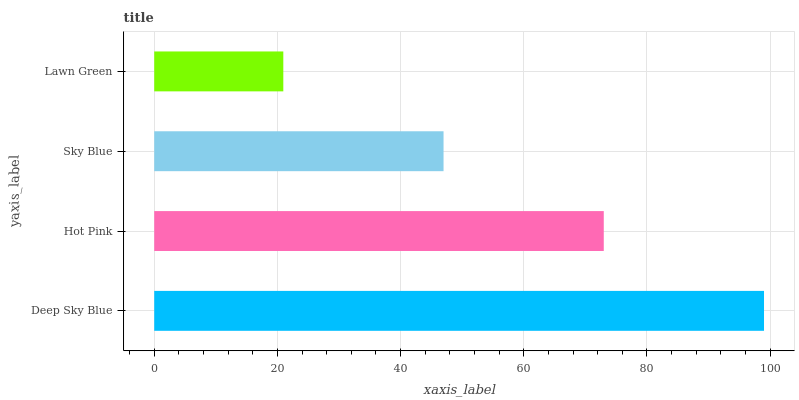Is Lawn Green the minimum?
Answer yes or no. Yes. Is Deep Sky Blue the maximum?
Answer yes or no. Yes. Is Hot Pink the minimum?
Answer yes or no. No. Is Hot Pink the maximum?
Answer yes or no. No. Is Deep Sky Blue greater than Hot Pink?
Answer yes or no. Yes. Is Hot Pink less than Deep Sky Blue?
Answer yes or no. Yes. Is Hot Pink greater than Deep Sky Blue?
Answer yes or no. No. Is Deep Sky Blue less than Hot Pink?
Answer yes or no. No. Is Hot Pink the high median?
Answer yes or no. Yes. Is Sky Blue the low median?
Answer yes or no. Yes. Is Lawn Green the high median?
Answer yes or no. No. Is Deep Sky Blue the low median?
Answer yes or no. No. 